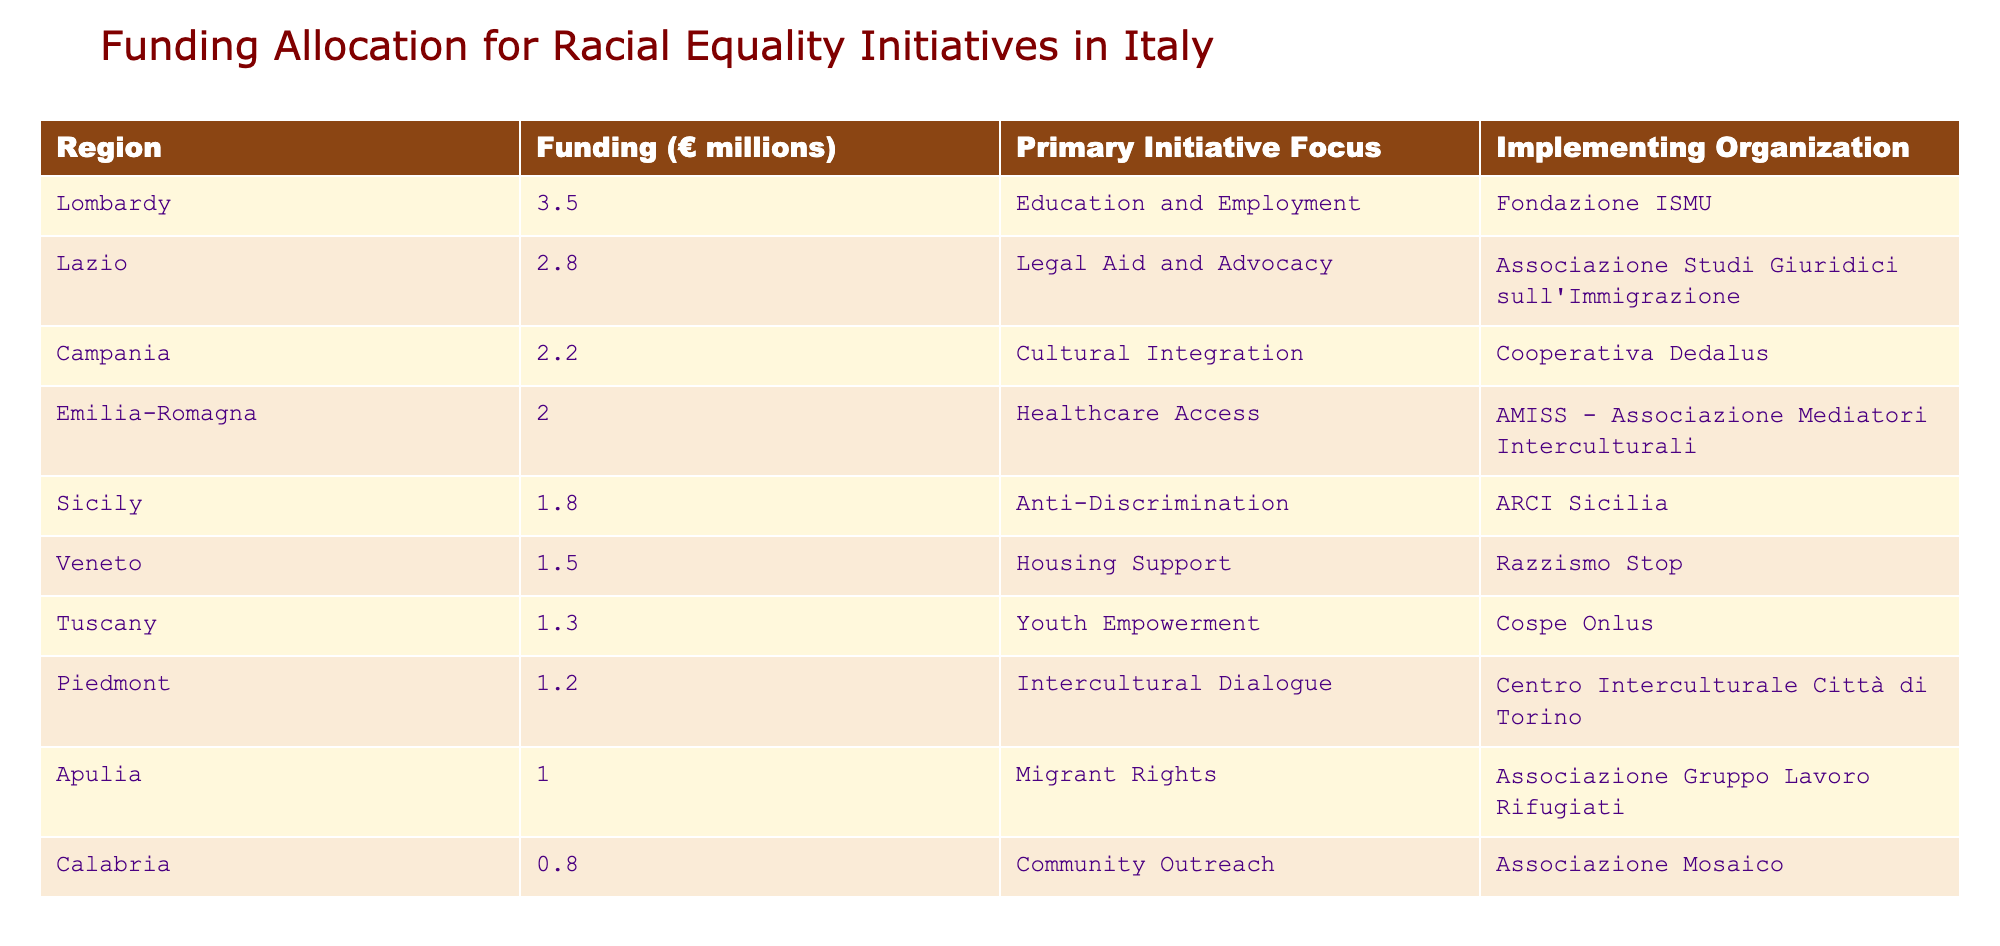What's the highest funding allocated for a racial equality initiative in Italy? The table shows the funding amounts for various regions. The highest funding is 3.5 million euros, allocated to Lombardy.
Answer: 3.5 million euros Which region focuses on cultural integration? The table lists each region along with its primary initiative focus. Campania is focused on cultural integration.
Answer: Campania What is the total funding allocated to initiatives in the regions of Calabria and Apulia? The funding for Calabria is 0.8 million euros and for Apulia is 1.0 million euros. Summing these amounts gives 0.8 + 1.0 = 1.8 million euros.
Answer: 1.8 million euros Is there any region that has funding above 2 million euros? A quick look at the table shows that Lombardy, Lazio, and Campania all have funding above 2 million euros. Therefore, the statement is true.
Answer: Yes What is the average funding amount across all listed regions? To find the average, we first sum the funding amounts: 3.5 + 2.8 + 2.2 + 2.0 + 1.8 + 1.5 + 1.3 + 1.2 + 1.0 + 0.8 = 18.1 million euros. There are 10 regions, so the average is 18.1 / 10 = 1.81 million euros.
Answer: 1.81 million euros Which organization implements the primary initiative focus of legal aid and advocacy? Looking at the table, the organization responsible for legal aid and advocacy in Lazio is the Associazione Studi Giuridici sull'Immigrazione.
Answer: Associazione Studi Giuridici sull'Immigrazione Is there any region focused on anti-discrimination initiatives? The table indicates that Sicily’s primary initiative is anti-discrimination. Hence, the answer is true.
Answer: Yes How much funding does Tuscany receive compared to Veneto? Tuscany receives 1.3 million euros, and Veneto receives 1.5 million euros. The difference is 1.5 - 1.3 = 0.2 million euros, so Veneto has more funding than Tuscany.
Answer: Veneto has 0.2 million euros more than Tuscany 